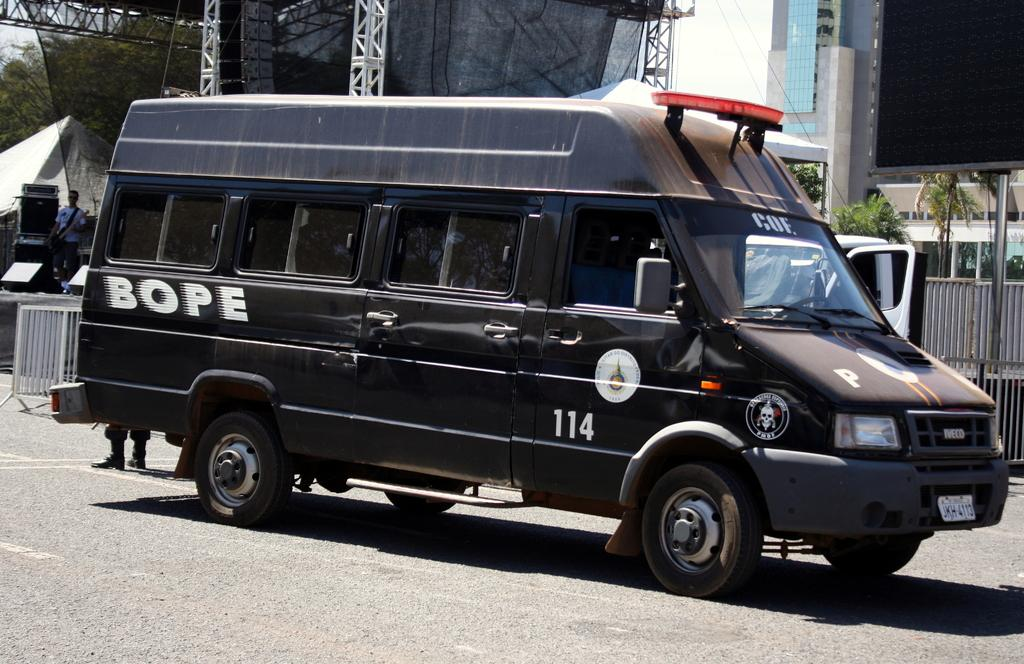<image>
Offer a succinct explanation of the picture presented. BOPE Van #114 sits parked on the street. 